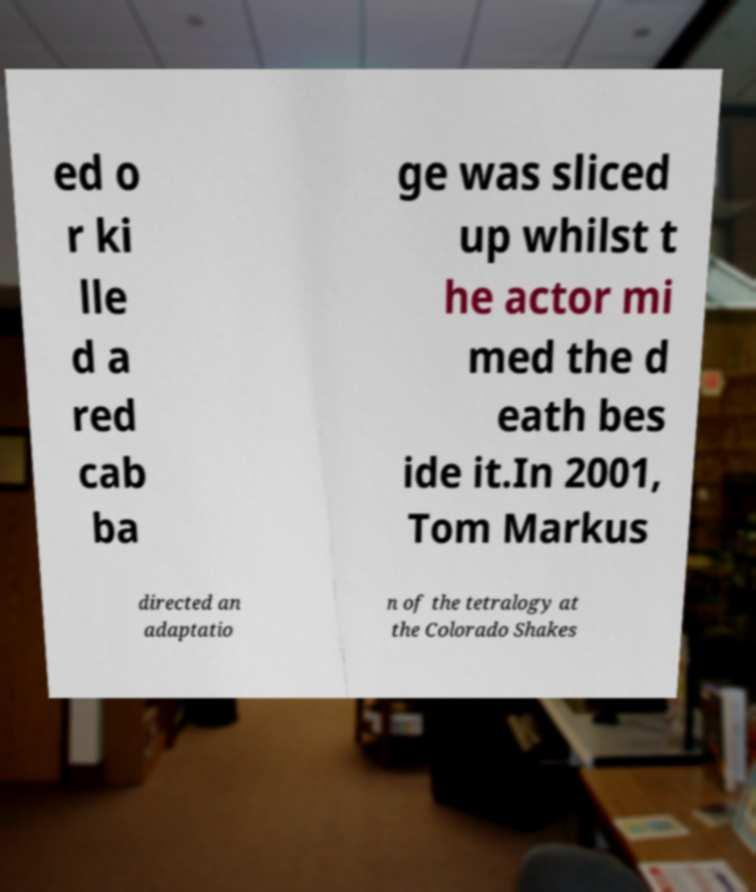For documentation purposes, I need the text within this image transcribed. Could you provide that? ed o r ki lle d a red cab ba ge was sliced up whilst t he actor mi med the d eath bes ide it.In 2001, Tom Markus directed an adaptatio n of the tetralogy at the Colorado Shakes 